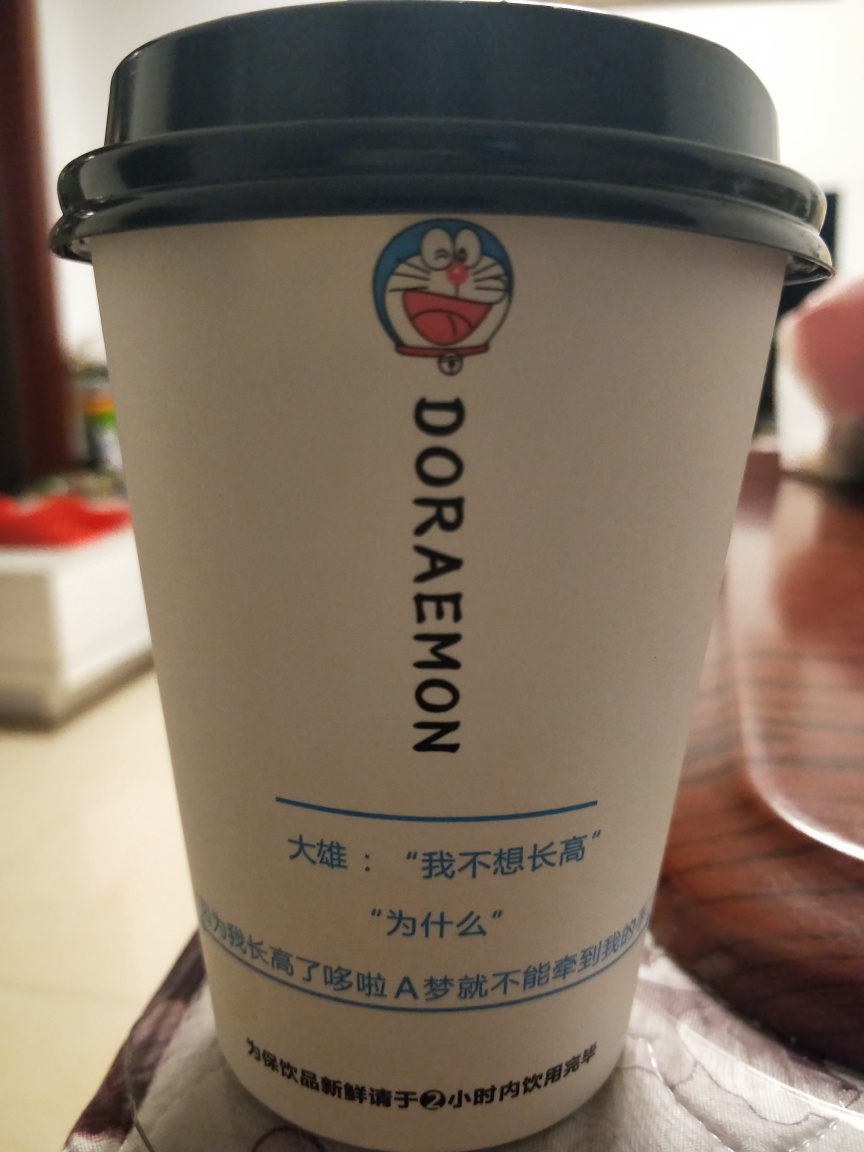What does the presence of the Doraemon character imply about the possible use or target audience of this cup? Doraemon, being a popular and beloved anime character, suggests that this cup is targeted towards fans of the series, which could include children and adults alike. It is designed to appeal to those who have an affection for this iconic character, and it might be used as a collectible item or as casual drinkware for everyday use. 